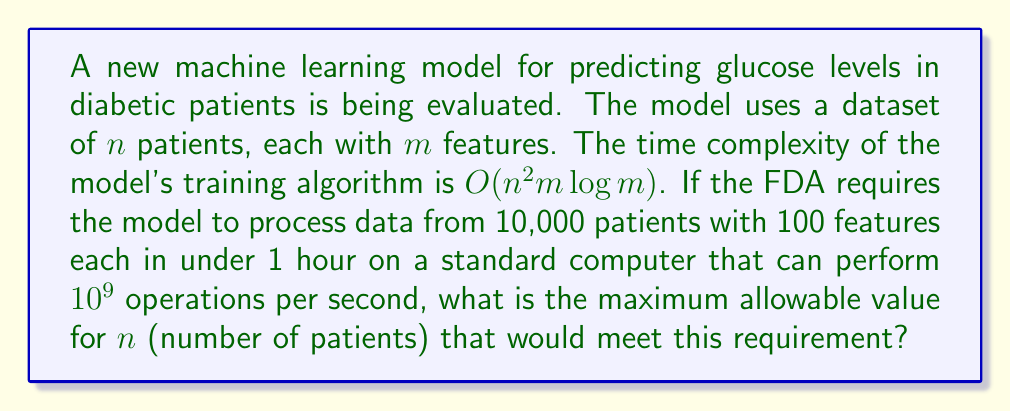Show me your answer to this math problem. To solve this problem, we need to follow these steps:

1) First, let's express the time complexity in terms of the number of operations:
   $\text{Number of operations} = c \cdot n^2m\log m$
   where $c$ is some constant factor.

2) We're given that $m = 100$ (features), so let's substitute this:
   $\text{Number of operations} = c \cdot n^2 \cdot 100 \cdot \log 100$
   $= c \cdot n^2 \cdot 100 \cdot 2 = 200c \cdot n^2$

3) The computer can perform $10^9$ operations per second, and we have 1 hour (3600 seconds) available. So the total number of operations allowed is:
   $3600 \cdot 10^9 = 3.6 \cdot 10^{12}$

4) Now we can set up an inequality:
   $200c \cdot n^2 \leq 3.6 \cdot 10^{12}$

5) Solving for $n$:
   $n^2 \leq \frac{3.6 \cdot 10^{12}}{200c}$
   $n \leq \sqrt{\frac{3.6 \cdot 10^{12}}{200c}}$

6) The constant $c$ is unknown, but we can assume it's at least 1 for a conservative estimate:
   $n \leq \sqrt{\frac{3.6 \cdot 10^{12}}{200}} = \sqrt{18 \cdot 10^9} \approx 134,164$

7) Since $n$ must be an integer, we round down to get the maximum allowable value.
Answer: The maximum allowable value for $n$ is 134,164 patients. 